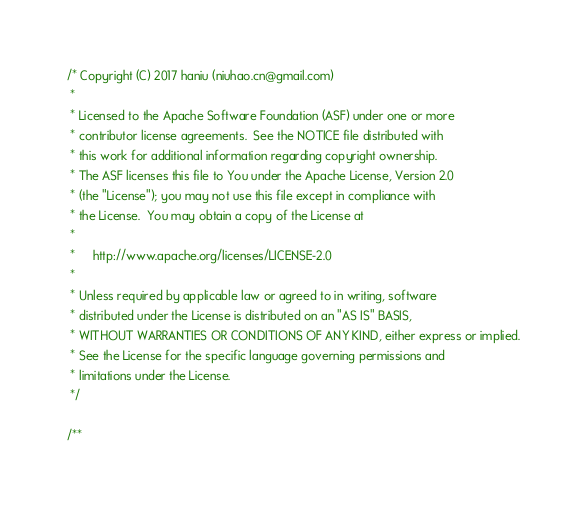Convert code to text. <code><loc_0><loc_0><loc_500><loc_500><_C_>/* Copyright (C) 2017 haniu (niuhao.cn@gmail.com)
 *
 * Licensed to the Apache Software Foundation (ASF) under one or more
 * contributor license agreements.  See the NOTICE file distributed with
 * this work for additional information regarding copyright ownership.
 * The ASF licenses this file to You under the Apache License, Version 2.0
 * (the "License"); you may not use this file except in compliance with
 * the License.  You may obtain a copy of the License at
 *
 *     http://www.apache.org/licenses/LICENSE-2.0
 *
 * Unless required by applicable law or agreed to in writing, software
 * distributed under the License is distributed on an "AS IS" BASIS,
 * WITHOUT WARRANTIES OR CONDITIONS OF ANY KIND, either express or implied.
 * See the License for the specific language governing permissions and
 * limitations under the License.
 */

/**</code> 